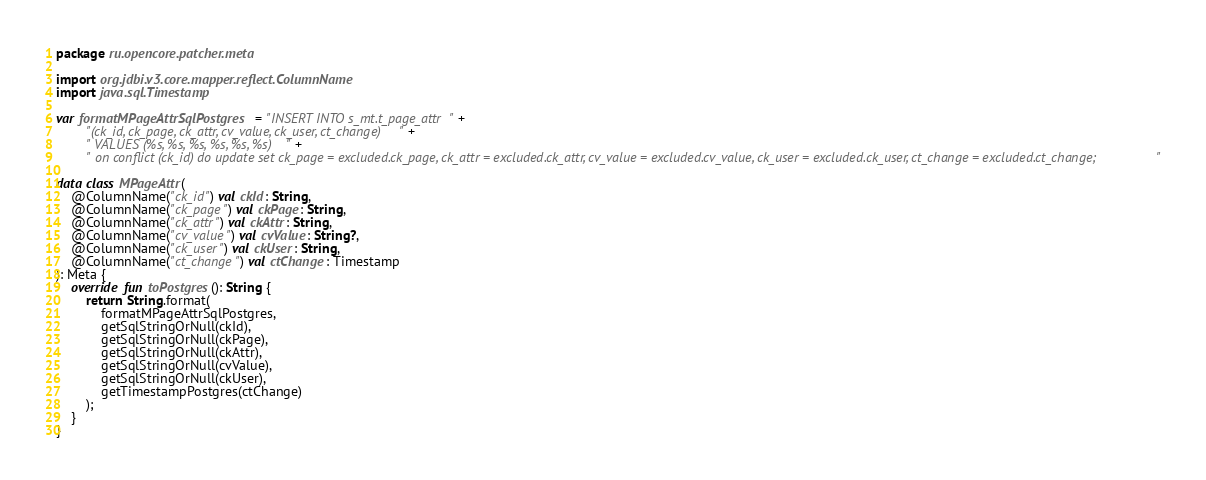Convert code to text. <code><loc_0><loc_0><loc_500><loc_500><_Kotlin_>package ru.opencore.patcher.meta

import org.jdbi.v3.core.mapper.reflect.ColumnName
import java.sql.Timestamp

var formatMPageAttrSqlPostgres = "INSERT INTO s_mt.t_page_attr" +
		"(ck_id, ck_page, ck_attr, cv_value, ck_user, ct_change)" +
		" VALUES (%s, %s, %s, %s, %s, %s) " +
		" on conflict (ck_id) do update set ck_page = excluded.ck_page, ck_attr = excluded.ck_attr, cv_value = excluded.cv_value, ck_user = excluded.ck_user, ct_change = excluded.ct_change;"

data class MPageAttr(
	@ColumnName("ck_id") val ckId: String,
	@ColumnName("ck_page") val ckPage: String,
	@ColumnName("ck_attr") val ckAttr: String,
	@ColumnName("cv_value") val cvValue: String?,
	@ColumnName("ck_user") val ckUser: String,
	@ColumnName("ct_change") val ctChange: Timestamp
): Meta {
	override fun toPostgres(): String {
		return String.format(
			formatMPageAttrSqlPostgres,
			getSqlStringOrNull(ckId),
			getSqlStringOrNull(ckPage),
			getSqlStringOrNull(ckAttr),
			getSqlStringOrNull(cvValue),
			getSqlStringOrNull(ckUser),
			getTimestampPostgres(ctChange)
		);
	}
}</code> 